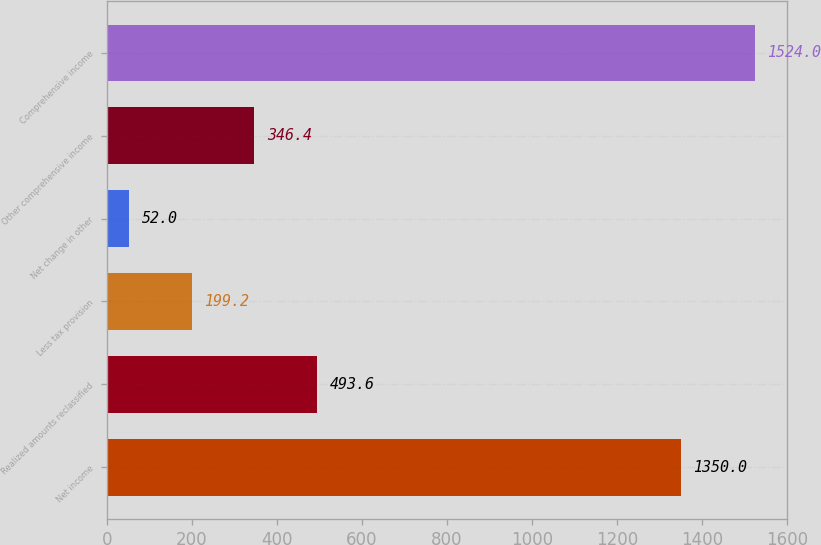Convert chart to OTSL. <chart><loc_0><loc_0><loc_500><loc_500><bar_chart><fcel>Net income<fcel>Realized amounts reclassified<fcel>Less tax provision<fcel>Net change in other<fcel>Other comprehensive income<fcel>Comprehensive income<nl><fcel>1350<fcel>493.6<fcel>199.2<fcel>52<fcel>346.4<fcel>1524<nl></chart> 